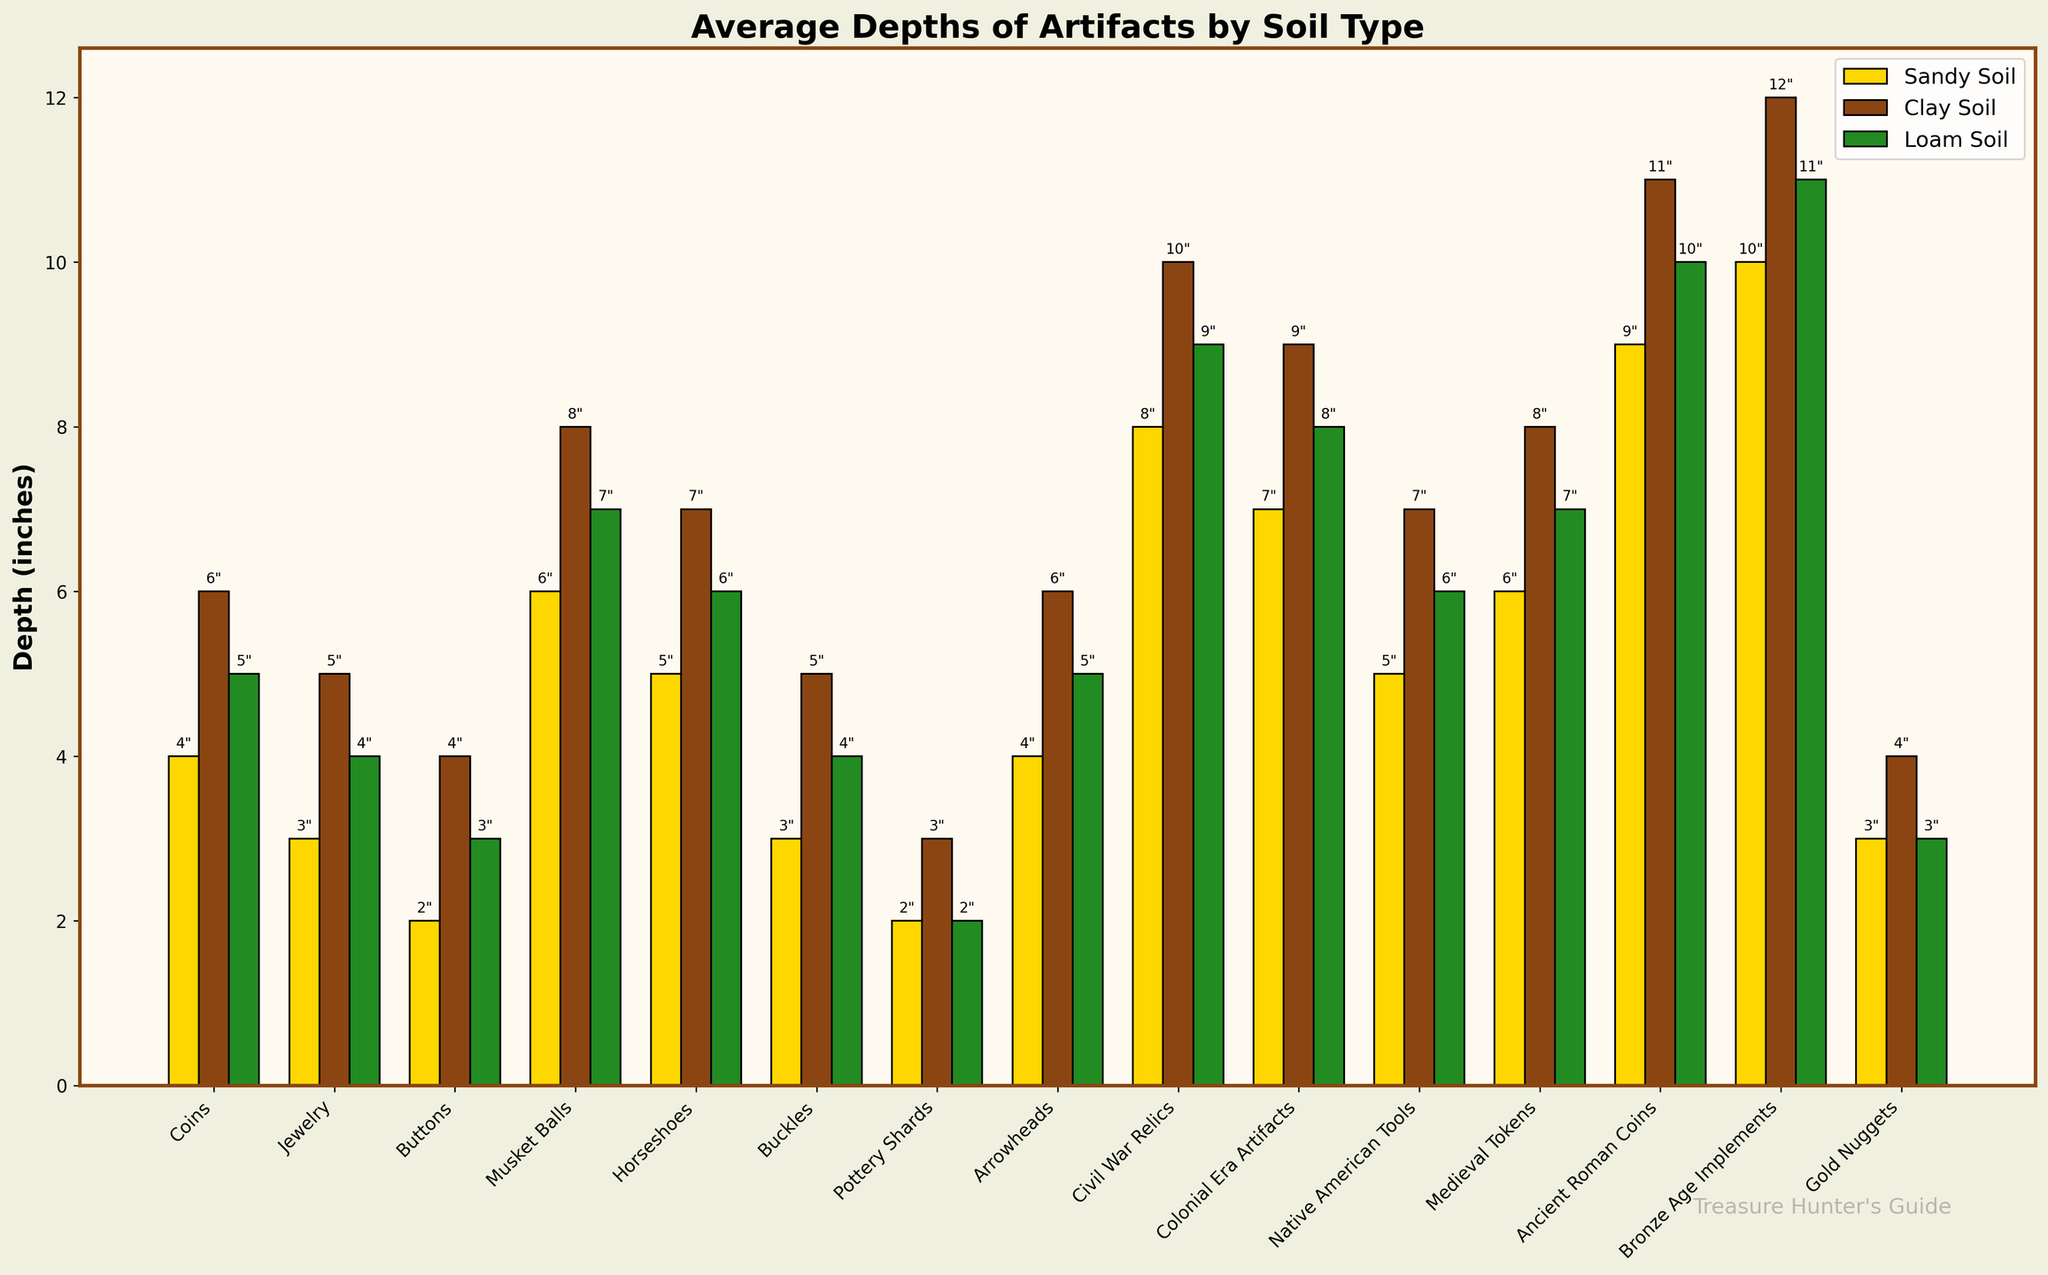Which artifact is found the deepest in sandy soil? By looking at the heights of the bars for "Sandy Soil", the tallest bar indicates the deepest depth. The artifact with the tallest bar in the "Sandy Soil" category is "Bronze Age Implements" at 10 inches.
Answer: Bronze Age Implements What is the average depth for Coins across all soil types? To find the average depth for Coins, sum the depths for all soil types (4 + 6 + 5) and divide by the number of soil types. This calculation yields (4+6+5)/3 = 15/3 = 5 inches.
Answer: 5 inches Which type of artifact is found shallower in loam soil compared to sandy soil? Scan through the bars for "Loam Soil" and "Sandy Soil", and identify which artifacts have a shorter bar in "Loam Soil". "Pottery Shards" have a shorter depth in loam soil (2 inches) compared to sandy soil (2 inches against 3 inches).
Answer: Pottery Shards What is the difference in depth between Colonial Era Artifacts found in clay soil and sandy soil? Look at the heights of the bars for Colonial Era Artifacts in both "Clay Soil" and "Sandy Soil". The depth in clay soil is 9 inches and in sandy soil is 7 inches. The difference is 9 - 7 = 2 inches.
Answer: 2 inches Which category of soil generally has the deepest artifacts? By comparing the average height for bars in "Sandy Soil", "Clay Soil", and "Loam Soil", "Clay Soil" generally shows the tallest bars, indicating it has deeper artifacts overall.
Answer: Clay Soil Among Native American Tools, which soil type shows the deepest average depth? For Native American Tools, look at the heights of the bars for each soil type and identify the tallest bar. It's greatest in "Clay Soil" at 7 inches.
Answer: Clay Soil What is the sum of the depths for Gold Nuggets across all soil types? Sum the bar heights for Gold Nuggets across all soil types: Sandy Soil (3 inches), Clay Soil (4 inches), and Loam Soil (3 inches). The sum is 3 + 4 + 3 = 10 inches.
Answer: 10 inches How much deeper are Ancient Roman Coins found in clay soil compared to loam soil? For Ancient Roman Coins, subtract the depth in loam soil (10 inches) from the depth in clay soil (11 inches). 11 - 10 = 1 inch.
Answer: 1 inch Which artifact exhibits the smallest depth variation across different soil types? Evaluate the range of depths for each artifact across the soils by comparing their highest and lowest values. "Pottery Shards" have depths of 2 inches across all solid types, exhibiting no variation.
Answer: Pottery Shards 